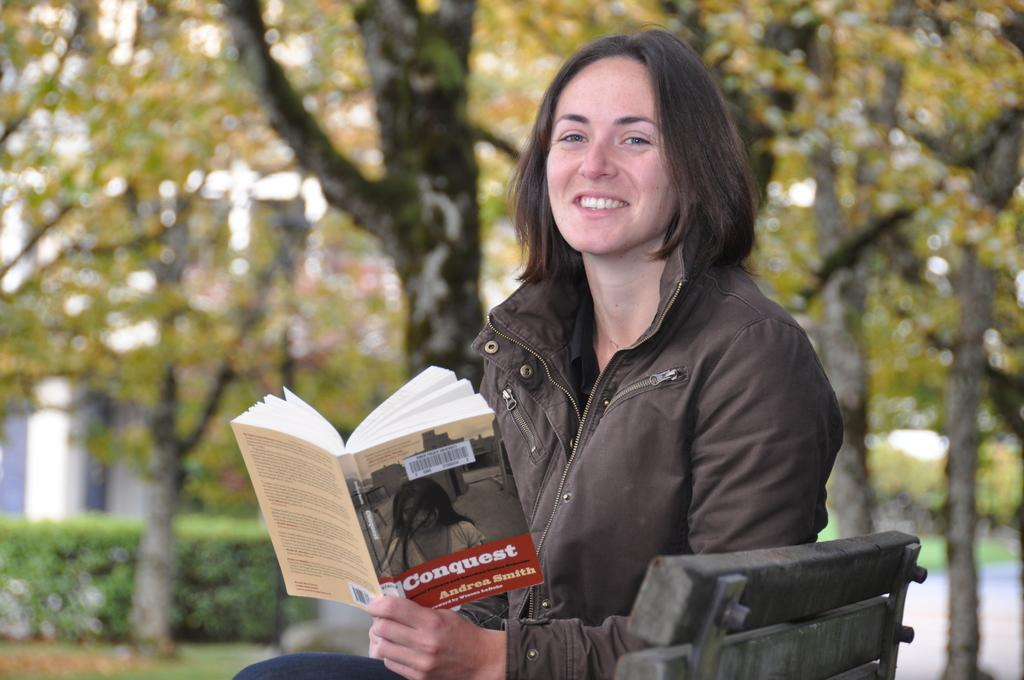<image>
Describe the image concisely. A woman reads a thin library paperback which is titled Conquest. 